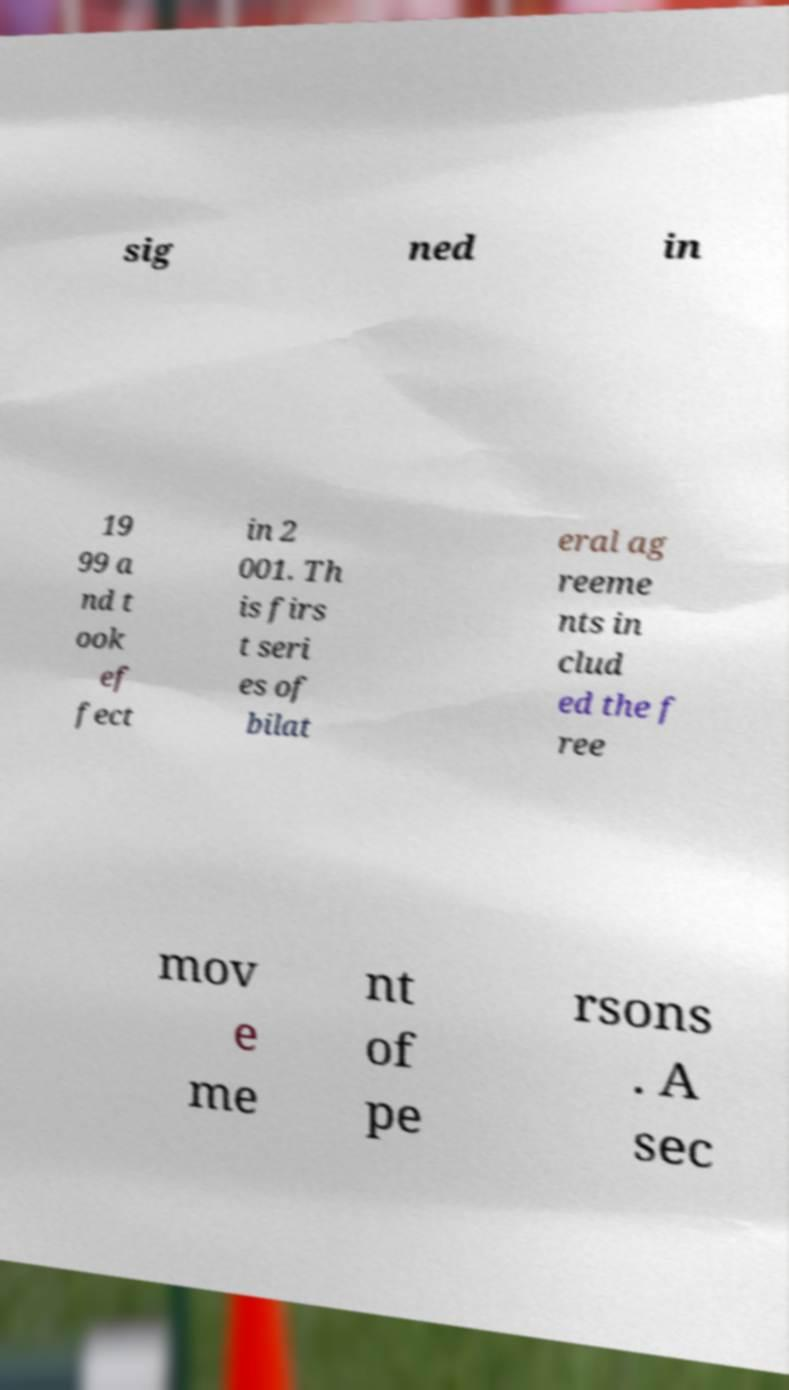There's text embedded in this image that I need extracted. Can you transcribe it verbatim? sig ned in 19 99 a nd t ook ef fect in 2 001. Th is firs t seri es of bilat eral ag reeme nts in clud ed the f ree mov e me nt of pe rsons . A sec 